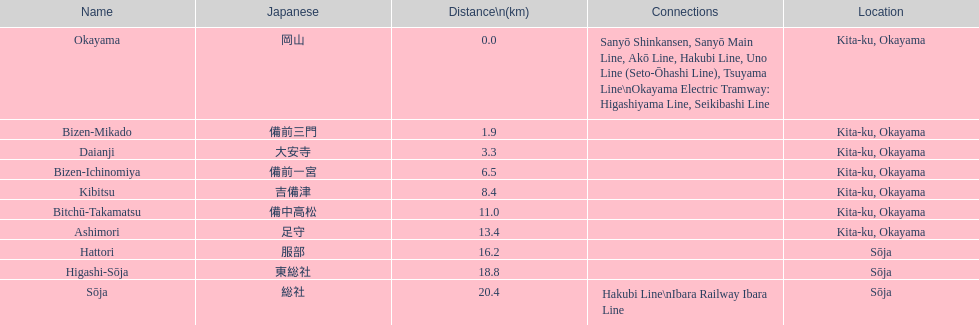How many stations are located within 15km? 7. 